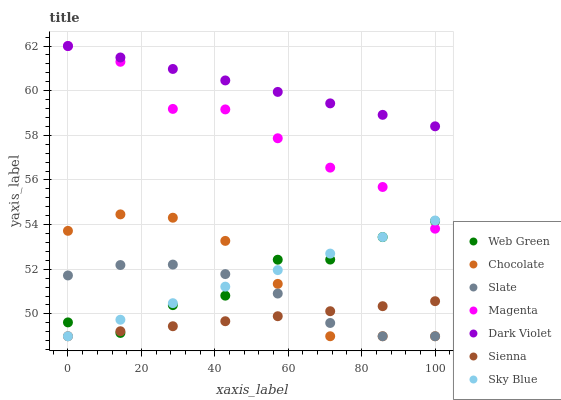Does Sienna have the minimum area under the curve?
Answer yes or no. Yes. Does Dark Violet have the maximum area under the curve?
Answer yes or no. Yes. Does Chocolate have the minimum area under the curve?
Answer yes or no. No. Does Chocolate have the maximum area under the curve?
Answer yes or no. No. Is Sienna the smoothest?
Answer yes or no. Yes. Is Web Green the roughest?
Answer yes or no. Yes. Is Dark Violet the smoothest?
Answer yes or no. No. Is Dark Violet the roughest?
Answer yes or no. No. Does Slate have the lowest value?
Answer yes or no. Yes. Does Dark Violet have the lowest value?
Answer yes or no. No. Does Magenta have the highest value?
Answer yes or no. Yes. Does Chocolate have the highest value?
Answer yes or no. No. Is Sienna less than Dark Violet?
Answer yes or no. Yes. Is Magenta greater than Slate?
Answer yes or no. Yes. Does Sky Blue intersect Chocolate?
Answer yes or no. Yes. Is Sky Blue less than Chocolate?
Answer yes or no. No. Is Sky Blue greater than Chocolate?
Answer yes or no. No. Does Sienna intersect Dark Violet?
Answer yes or no. No. 